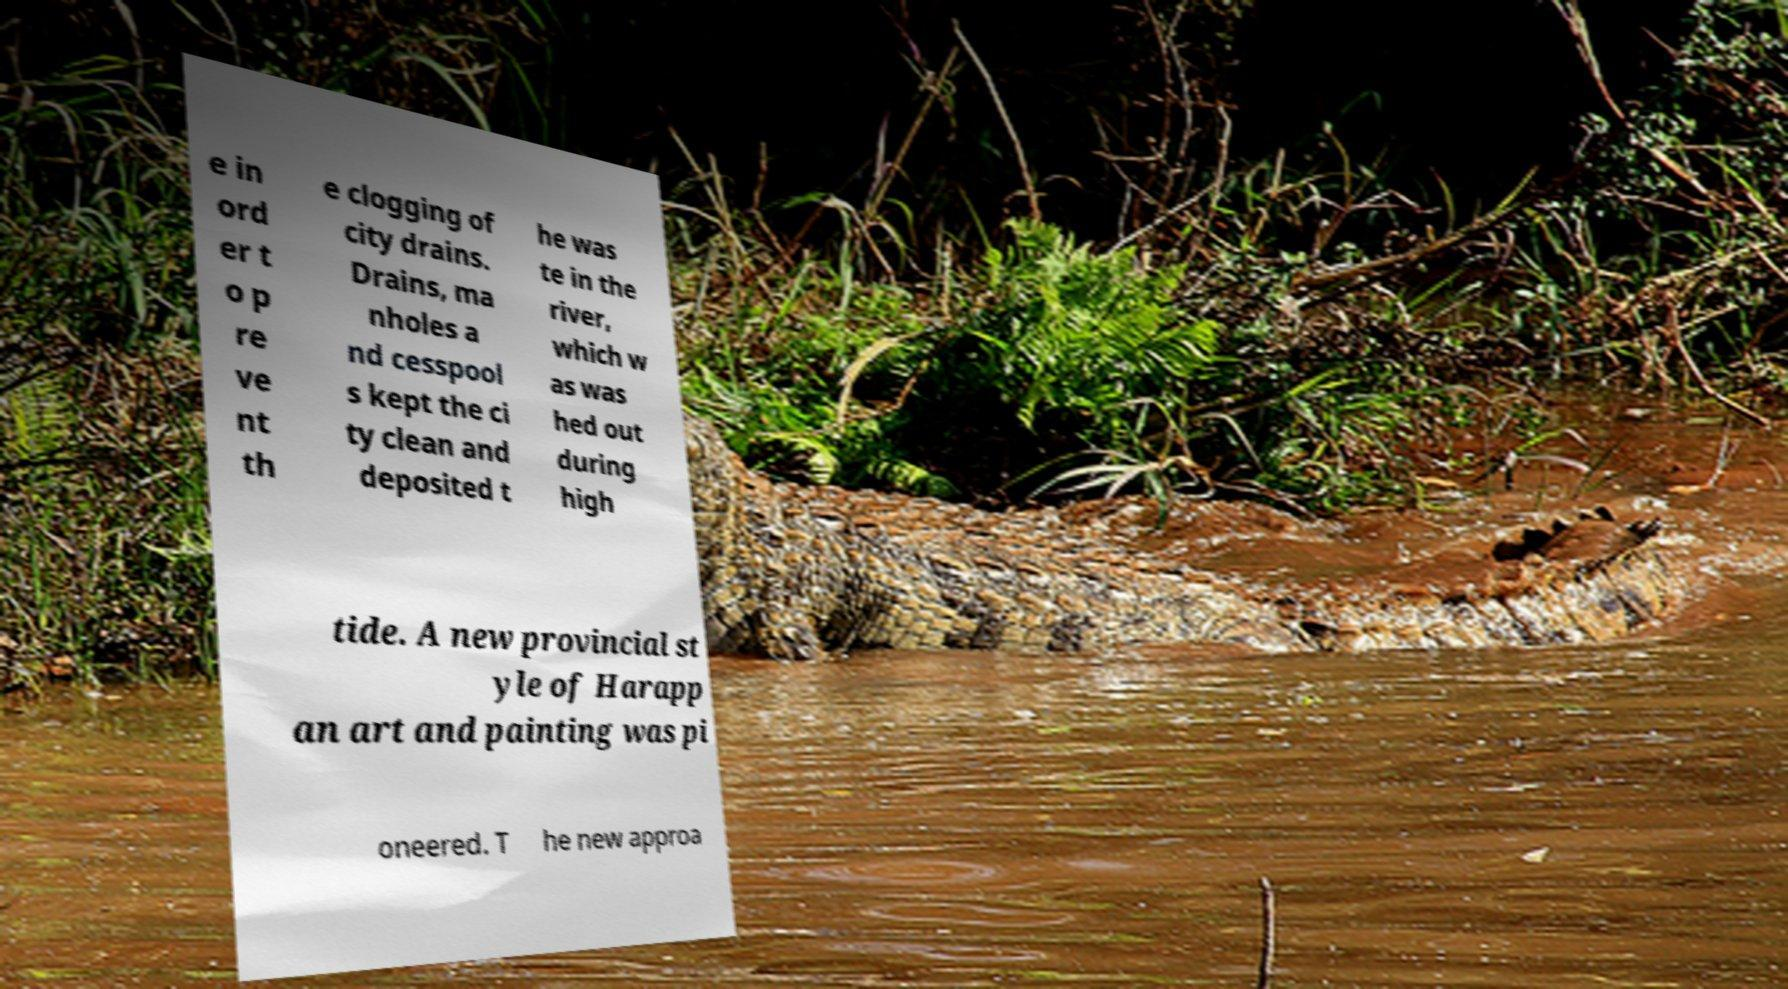Could you assist in decoding the text presented in this image and type it out clearly? e in ord er t o p re ve nt th e clogging of city drains. Drains, ma nholes a nd cesspool s kept the ci ty clean and deposited t he was te in the river, which w as was hed out during high tide. A new provincial st yle of Harapp an art and painting was pi oneered. T he new approa 